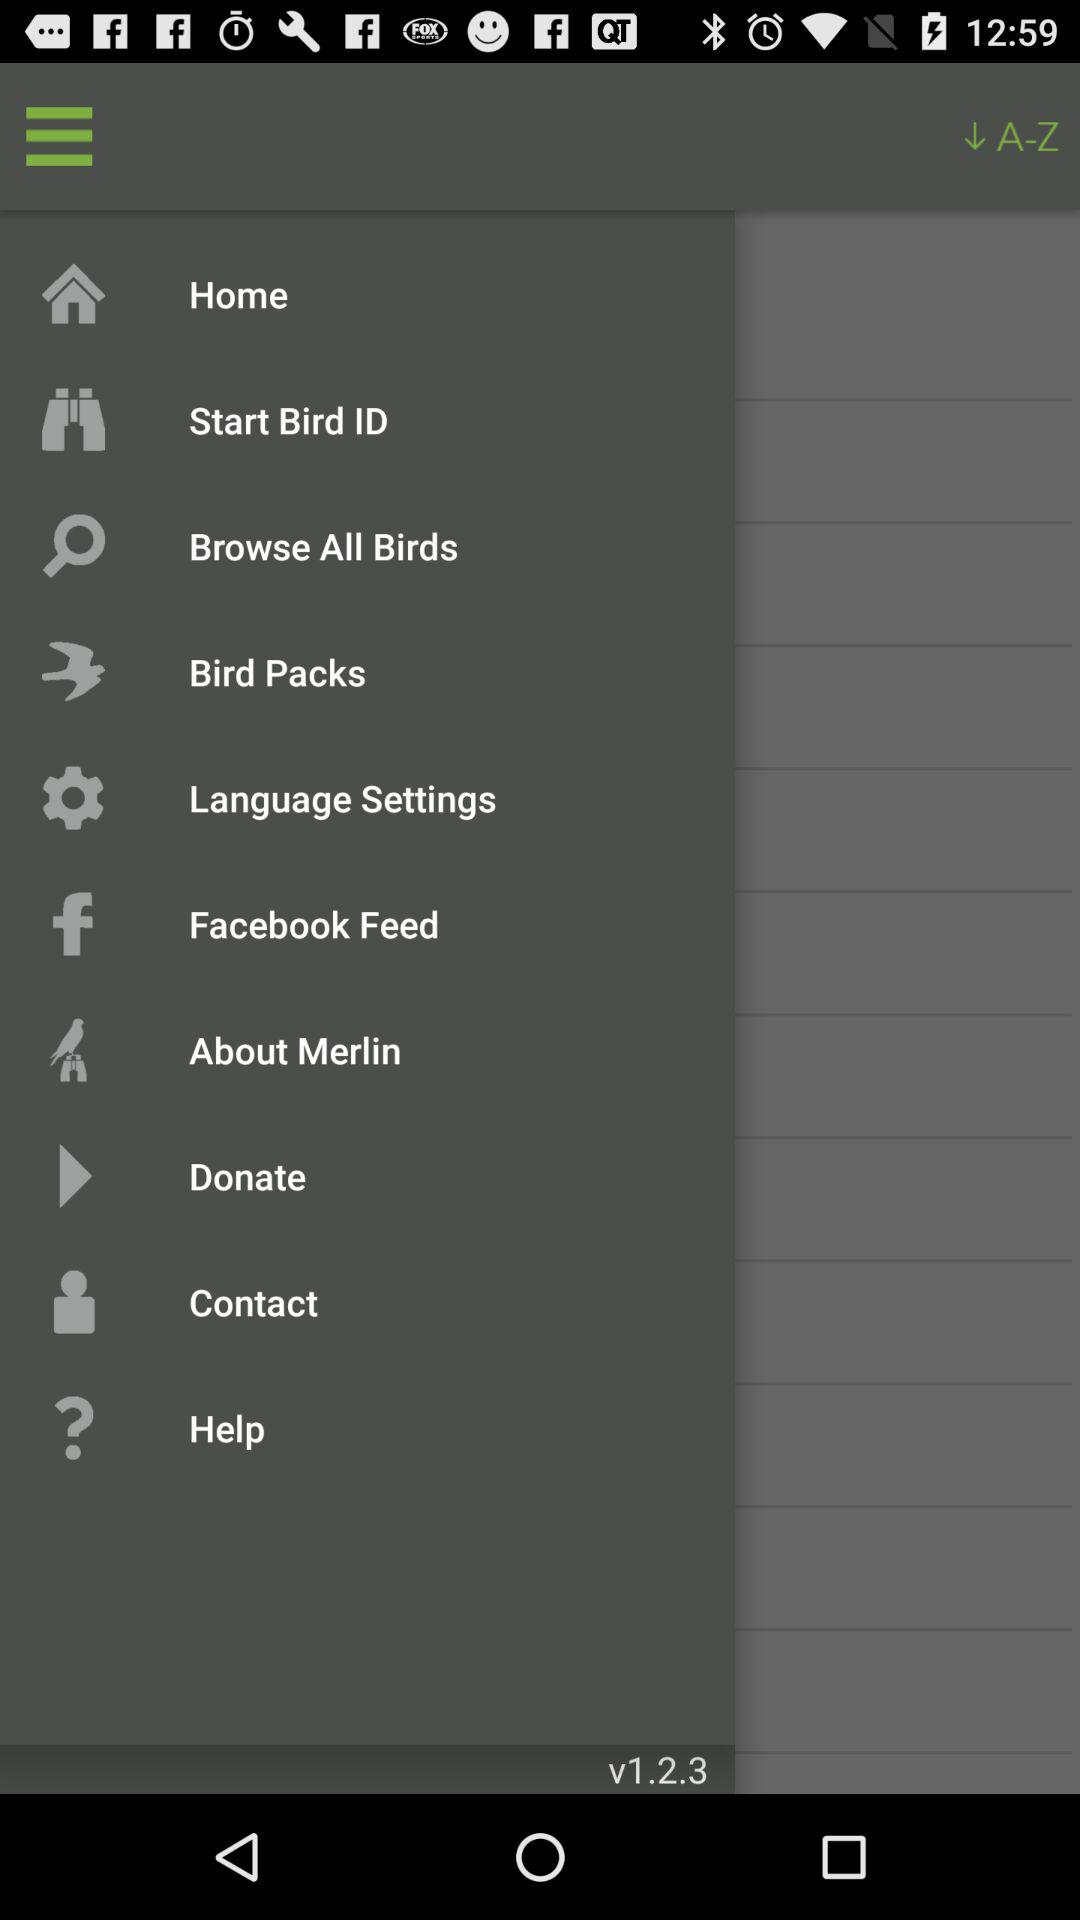How many notifications are there in "Contact"?
When the provided information is insufficient, respond with <no answer>. <no answer> 